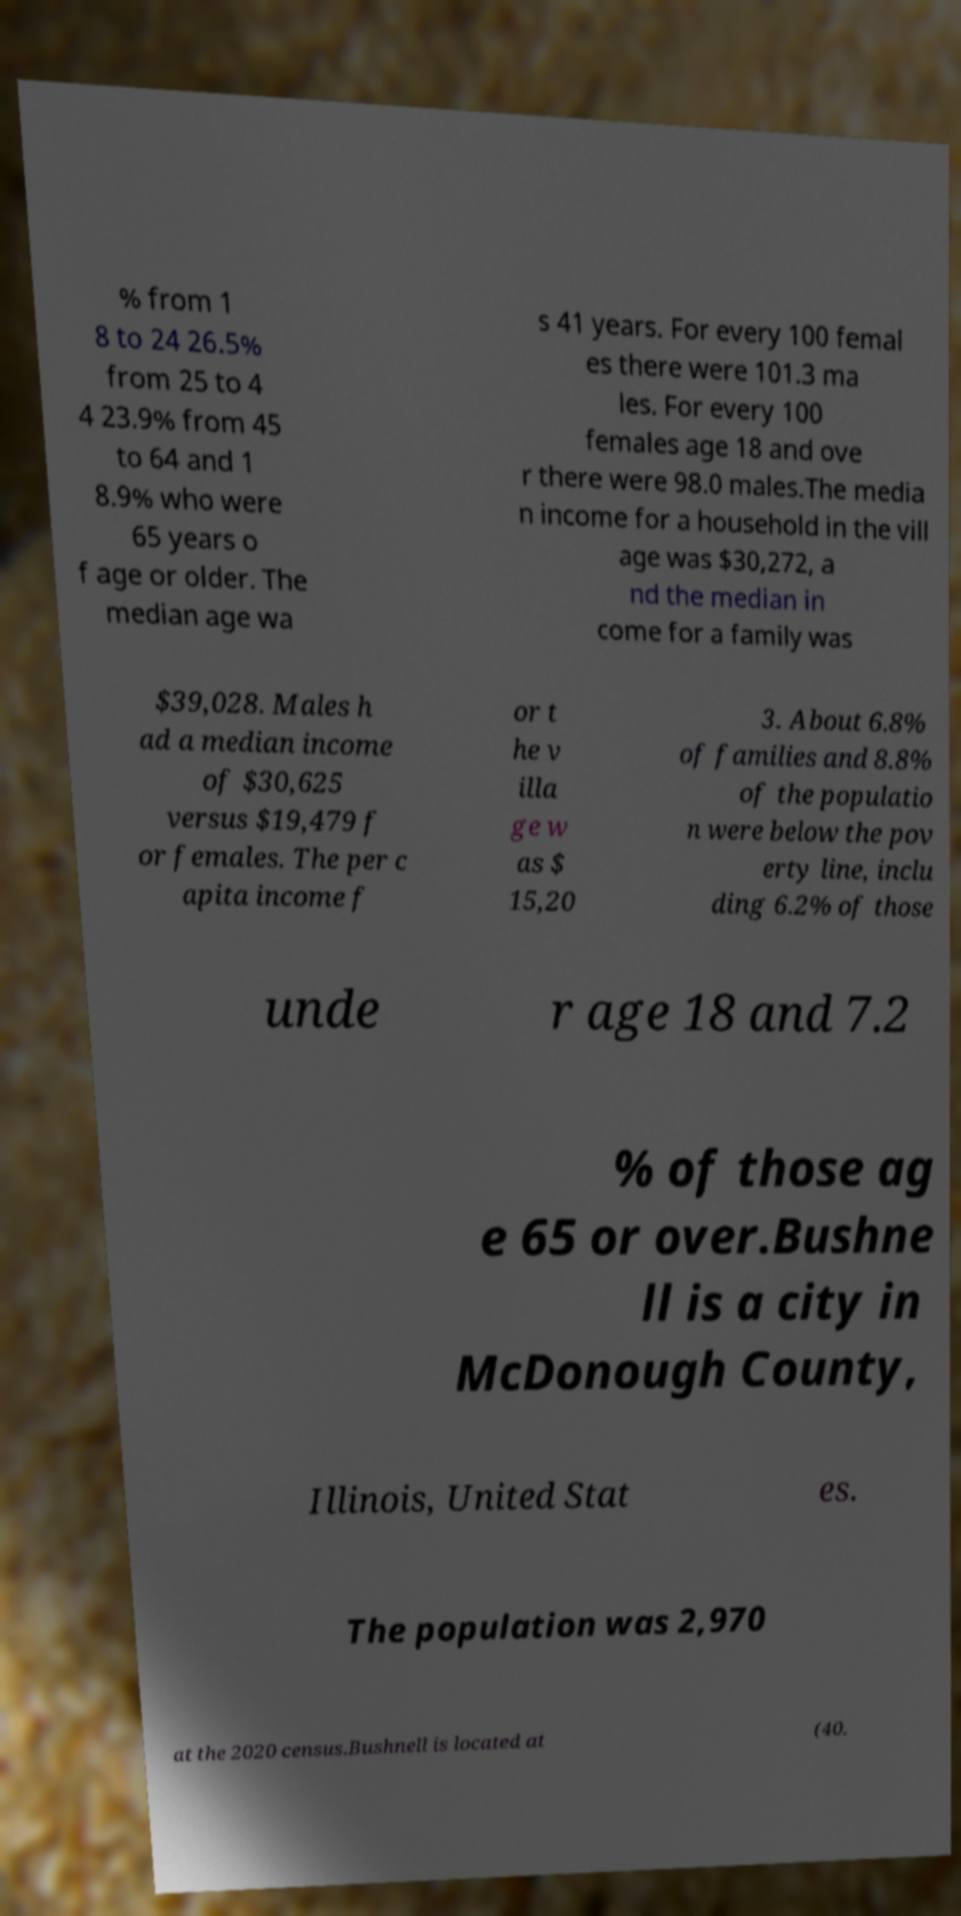Please identify and transcribe the text found in this image. % from 1 8 to 24 26.5% from 25 to 4 4 23.9% from 45 to 64 and 1 8.9% who were 65 years o f age or older. The median age wa s 41 years. For every 100 femal es there were 101.3 ma les. For every 100 females age 18 and ove r there were 98.0 males.The media n income for a household in the vill age was $30,272, a nd the median in come for a family was $39,028. Males h ad a median income of $30,625 versus $19,479 f or females. The per c apita income f or t he v illa ge w as $ 15,20 3. About 6.8% of families and 8.8% of the populatio n were below the pov erty line, inclu ding 6.2% of those unde r age 18 and 7.2 % of those ag e 65 or over.Bushne ll is a city in McDonough County, Illinois, United Stat es. The population was 2,970 at the 2020 census.Bushnell is located at (40. 